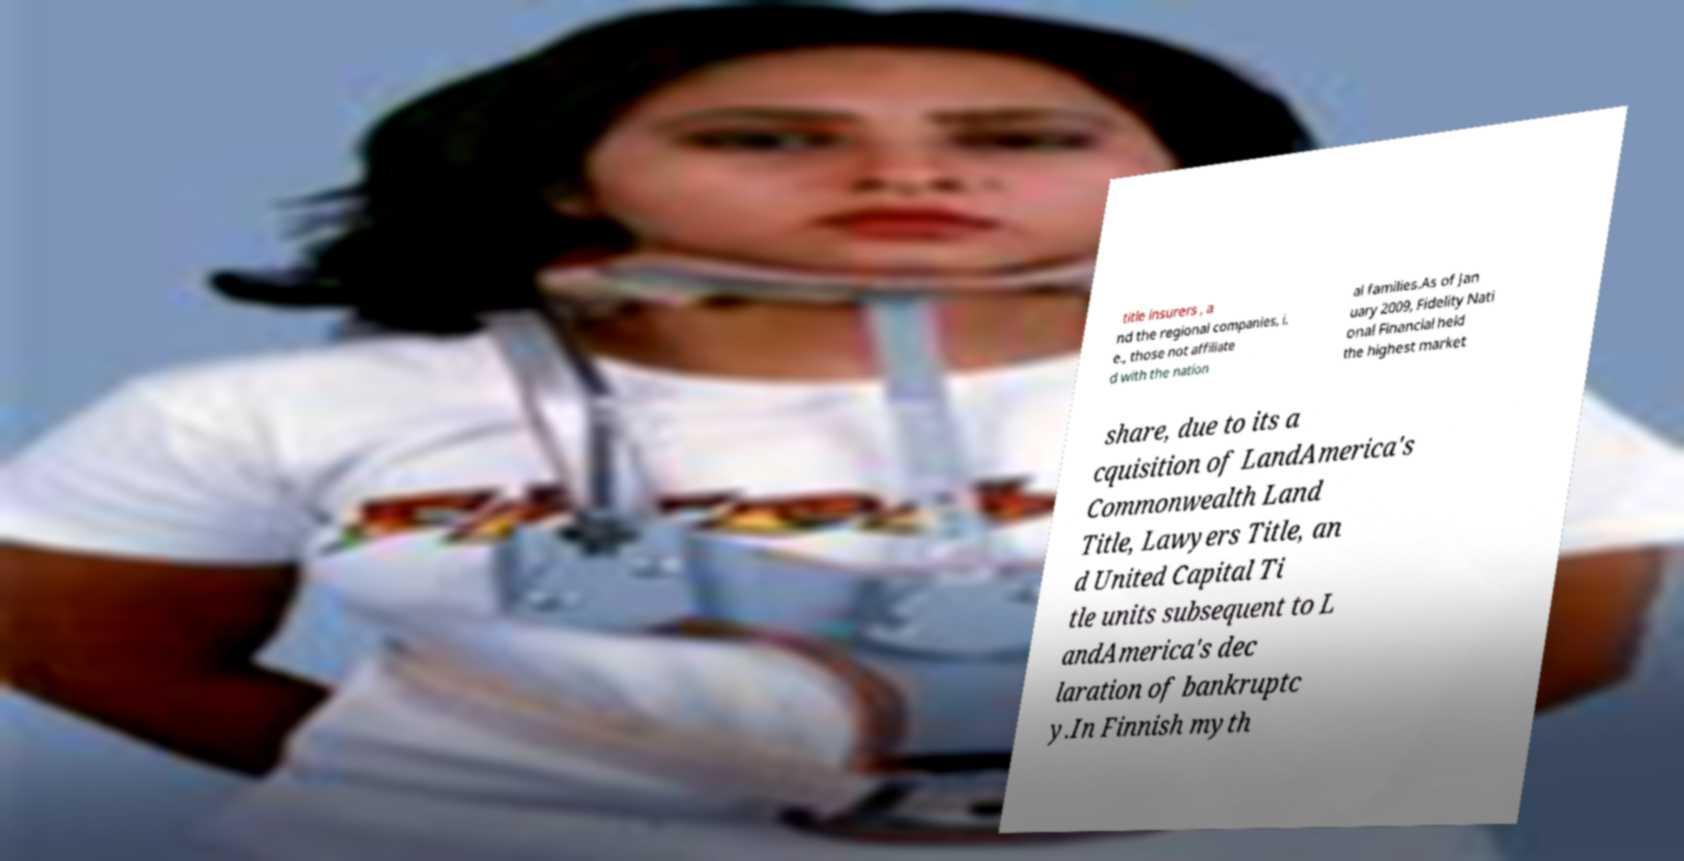Can you accurately transcribe the text from the provided image for me? title insurers , a nd the regional companies, i. e., those not affiliate d with the nation al families.As of Jan uary 2009, Fidelity Nati onal Financial held the highest market share, due to its a cquisition of LandAmerica's Commonwealth Land Title, Lawyers Title, an d United Capital Ti tle units subsequent to L andAmerica's dec laration of bankruptc y.In Finnish myth 